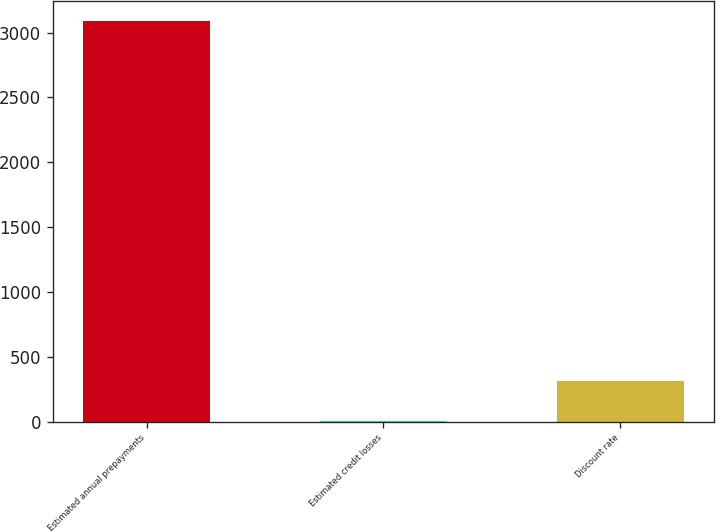Convert chart. <chart><loc_0><loc_0><loc_500><loc_500><bar_chart><fcel>Estimated annual prepayments<fcel>Estimated credit losses<fcel>Discount rate<nl><fcel>3090<fcel>3.6<fcel>312.24<nl></chart> 